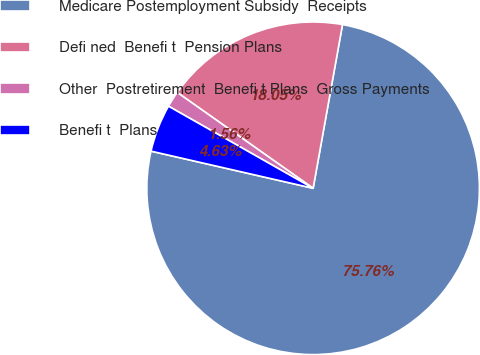Convert chart to OTSL. <chart><loc_0><loc_0><loc_500><loc_500><pie_chart><fcel>Medicare Postemployment Subsidy  Receipts<fcel>Defi ned  Benefi t  Pension Plans<fcel>Other  Postretirement  Benefi t Plans  Gross Payments<fcel>Benefi t  Plans<nl><fcel>75.76%<fcel>18.05%<fcel>1.56%<fcel>4.63%<nl></chart> 